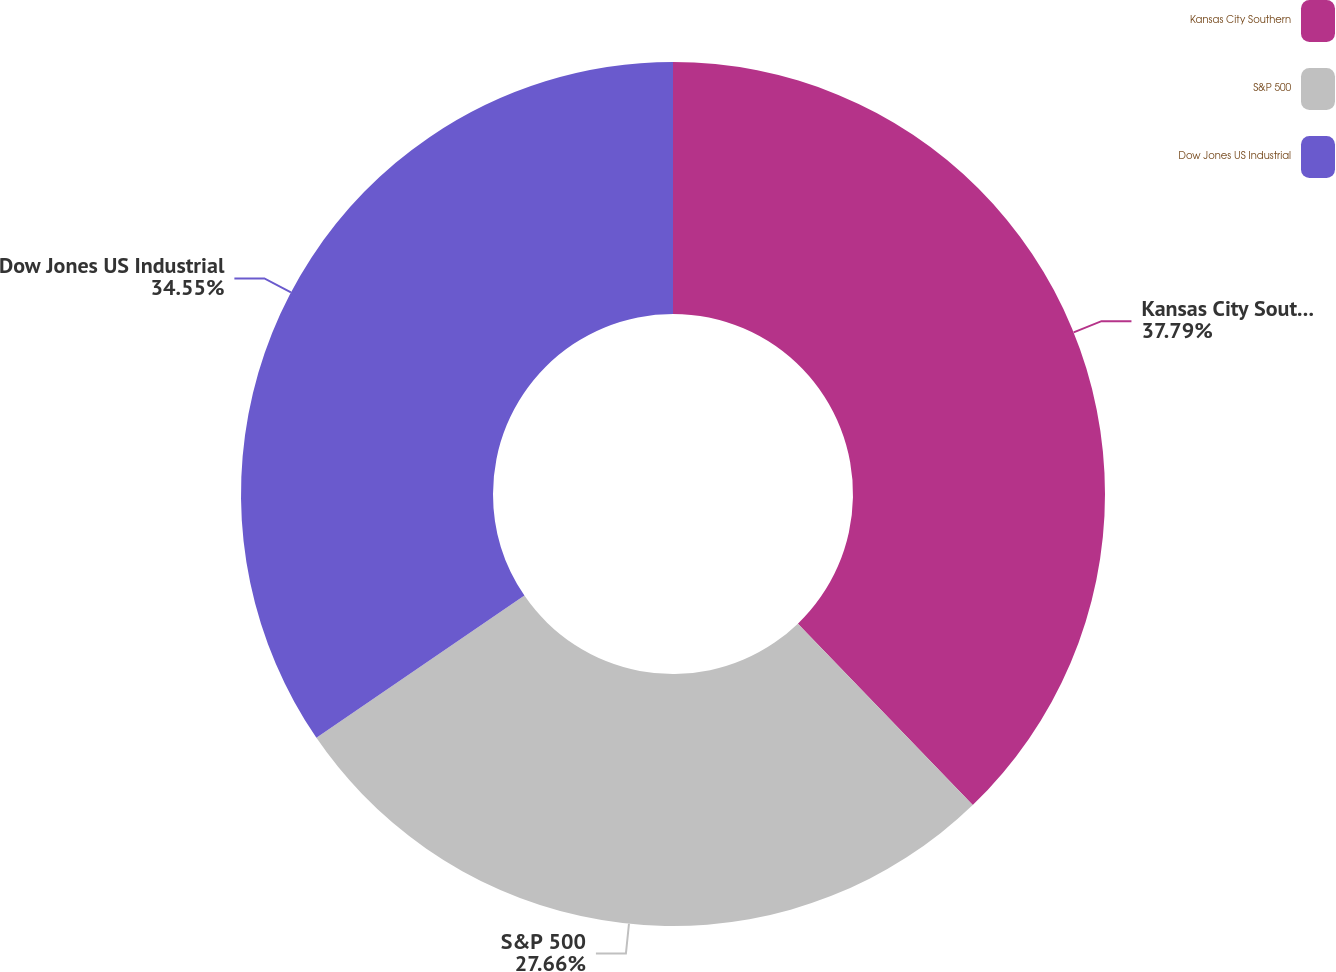Convert chart to OTSL. <chart><loc_0><loc_0><loc_500><loc_500><pie_chart><fcel>Kansas City Southern<fcel>S&P 500<fcel>Dow Jones US Industrial<nl><fcel>37.8%<fcel>27.66%<fcel>34.55%<nl></chart> 